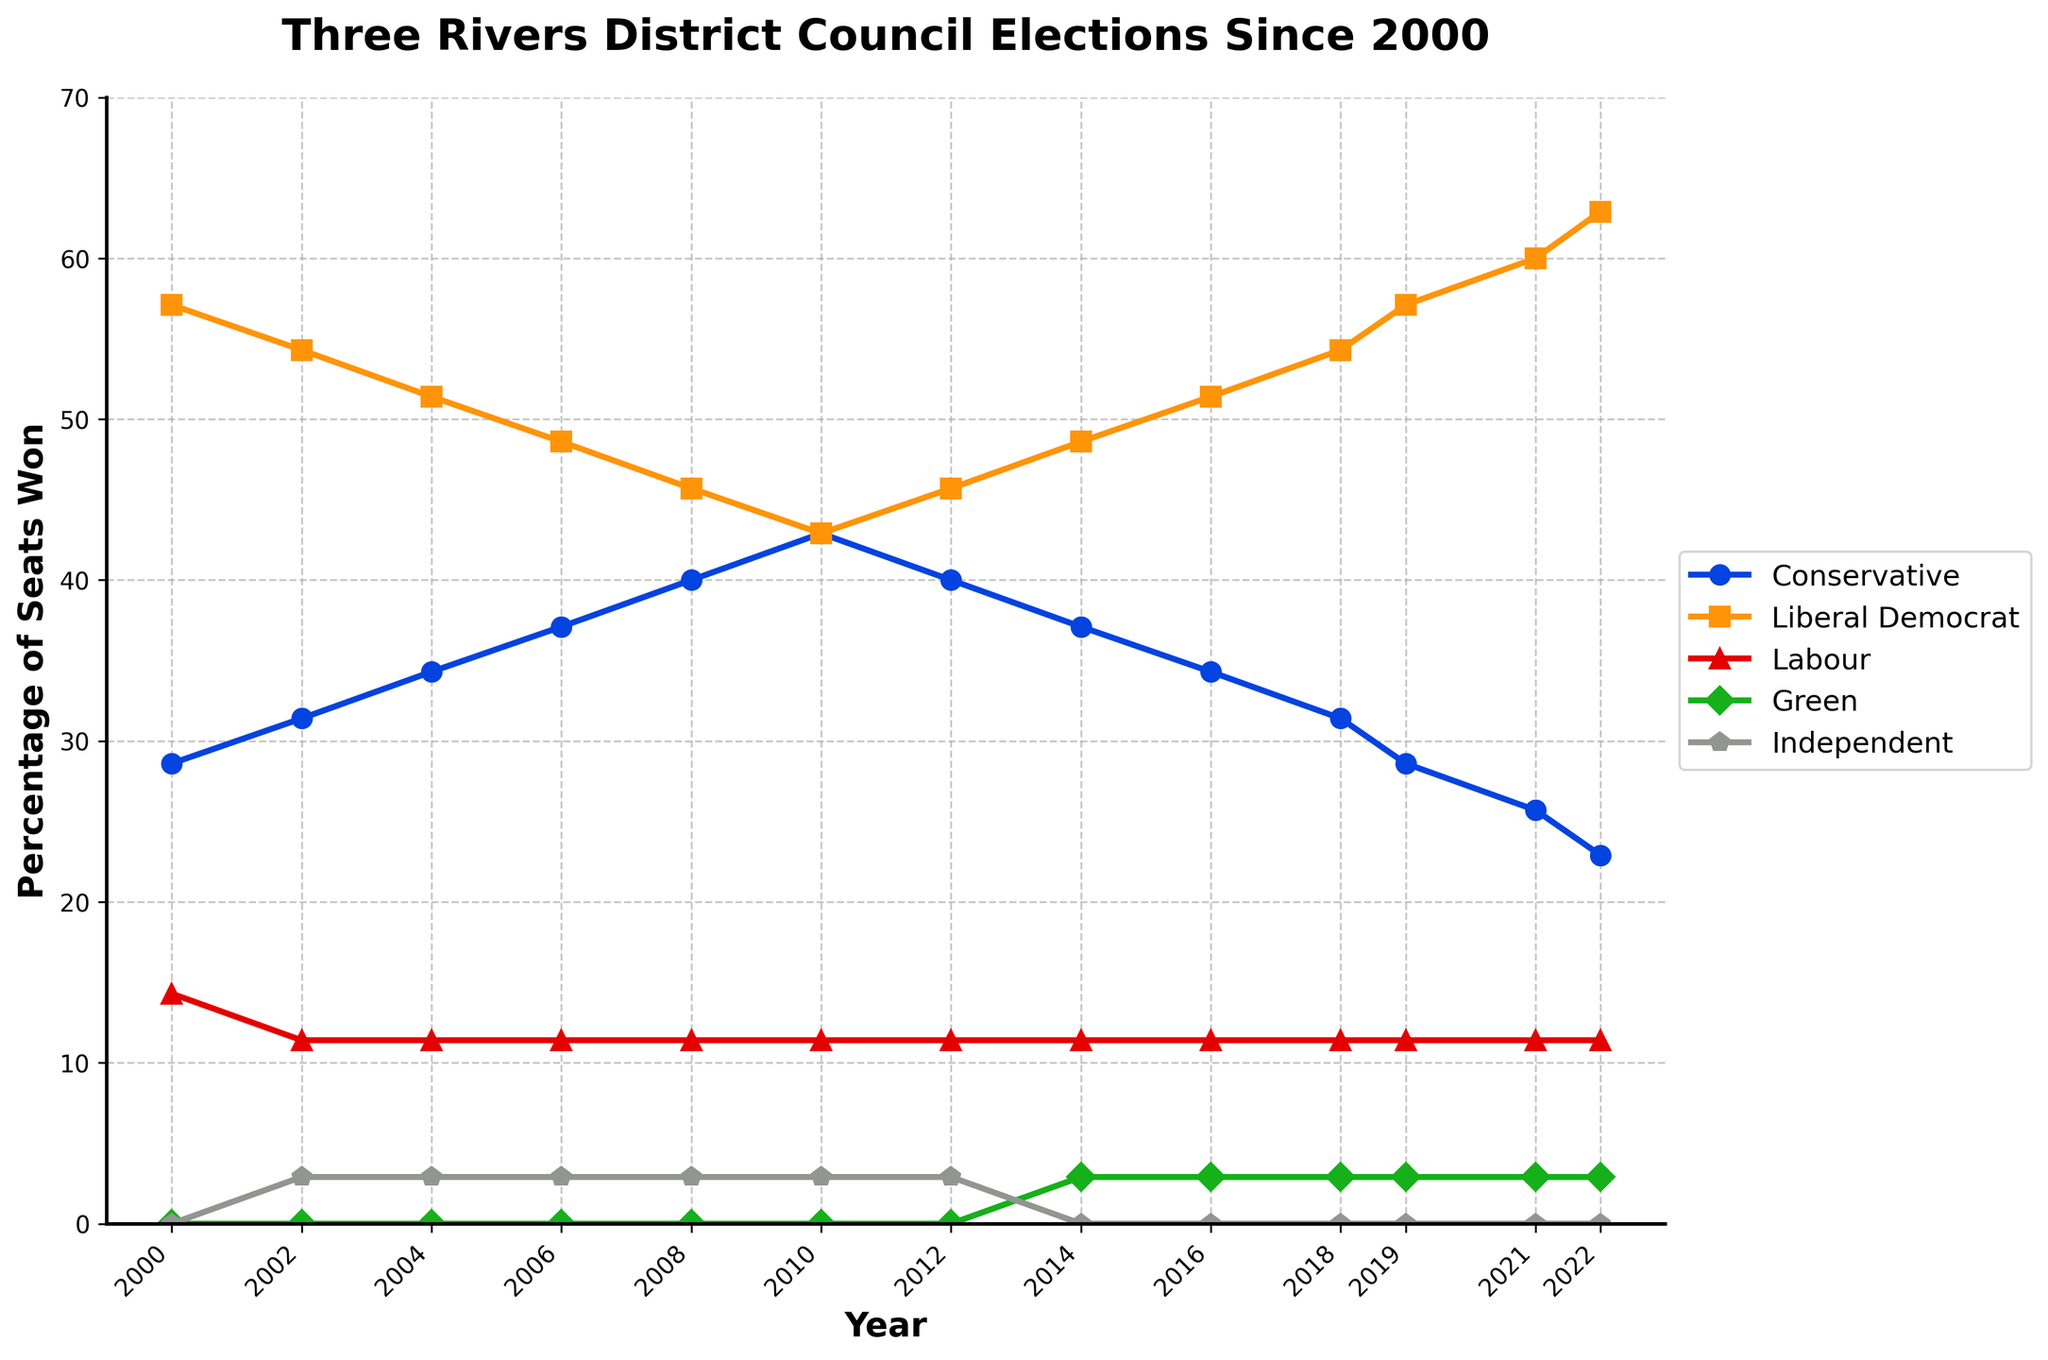What party had the highest percentage of seats in 2000? The figure shows different lines representing the percentage of seats won by each party over time. In 2000, the Liberal Democrat line is at the top.
Answer: Liberal Democrat Has the percentage of seats won by the Conservative Party generally increased or decreased from 2000 to 2022? The figure shows the Conservative Party percentage starting at around 28.6% in 2000 and decreasing to about 22.9% in 2022.
Answer: Decreased In which year did the Green Party first win any seats? The Green Party line first appears above 0% in 2014.
Answer: 2014 What is the difference between the percentages of seats won by the Conservative and Liberal Democrat parties in 2022? In 2022, the Conservative Party had around 22.9% and the Liberal Democrat Party had about 62.9%. The difference is 62.9% - 22.9%.
Answer: 40% Which party had the smallest percentage change in seats won between 2000 and 2022? The figure shows the Labour Party's line is relatively flat, starting at 14.3% in 2000 and ending at 11.4% in 2022.
Answer: Labour By how much did the percentage of seats won by the Green Party change from their first win in 2014 to 2022? The figure shows the Green Party’s percentage at their first win in 2014 at 2.9% and it remains at 2.9% in 2022. The change is 2.9% - 2.9%.
Answer: 0% In what year did the Independent candidates win seats, and how many times did this occur? The figure shows Independent candidates winning seats only in 2002, as indicated by the presence of their line just above 0% only in that year.
Answer: 2002, once Which two parties had nearly equal percentages of seats in 2010, and what were these percentages? The figure shows the lines for the Conservative and Liberal Democrat parties meeting around 42.9% in 2010.
Answer: Conservative and Liberal Democrat, 42.9% How many times did the percentage of seats won by Labour remain constant throughout the period shown? The Labour Party’s line seems to remain at 11.4% without variation throughout the entire period shown in the figure.
Answer: Constant throughout What is the average percentage of seats won by the Liberal Democrat Party over the entire period shown? First, collect the percentages for Liberal Democrat: 57.1, 54.3, 51.4, 48.6, 45.7, 42.9, 45.7, 48.6, 51.4, 54.3, 57.1, 60.0, 62.9. Sum them up (632.0) and divide by the number of years (13).
Answer: 48.6 